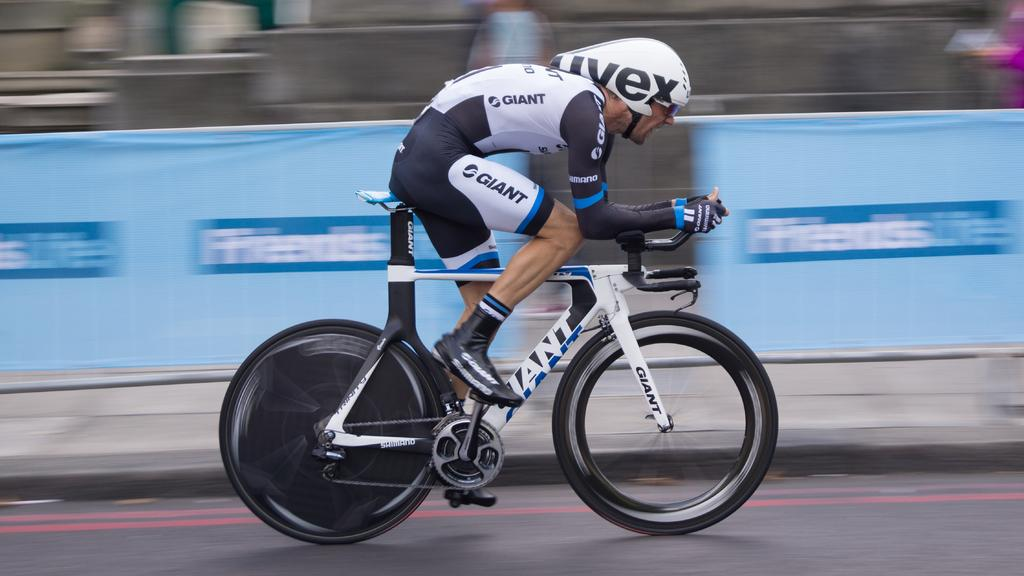<image>
Create a compact narrative representing the image presented. A man is on a bike with the word giant on his shirt and shorts. 